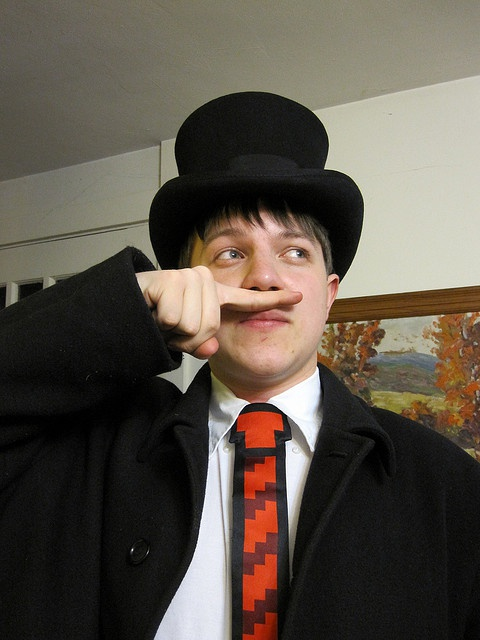Describe the objects in this image and their specific colors. I can see people in black, gray, lightgray, tan, and maroon tones and tie in gray, black, red, and maroon tones in this image. 